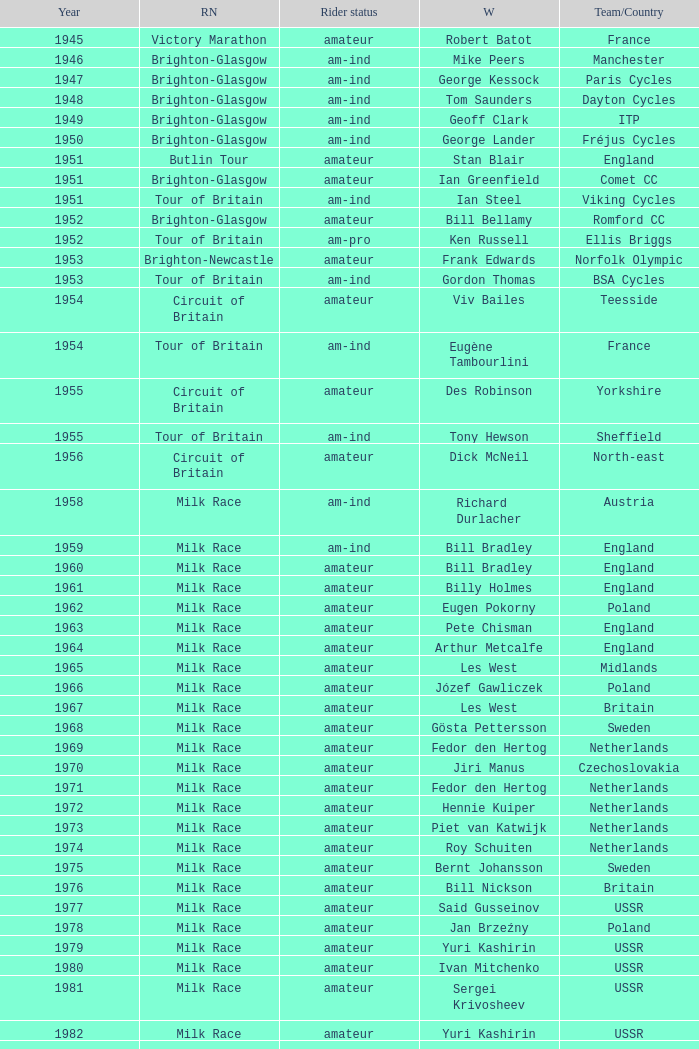What is the latest year when Phil Anderson won? 1993.0. 